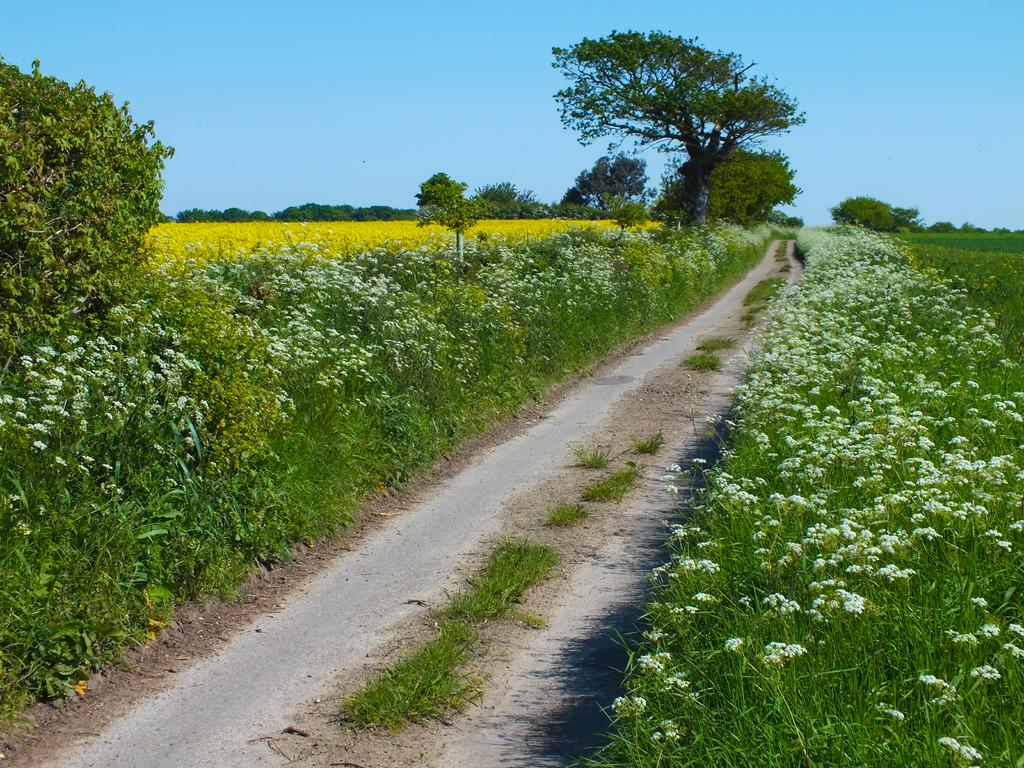What is located in the center of the image? There are plants, flowers, and trees in the center of the image. What can be seen at the bottom of the image? There is a road and grass at the bottom of the image. What is visible at the top of the image? The sky is visible at the top of the image. What type of mint is growing in the center of the image? There is no mint present in the image; it features plants, flowers, and trees. What message of hope can be seen in the image? There is no message of hope depicted in the image; it focuses on the plants, flowers, trees, road, grass, and sky. 